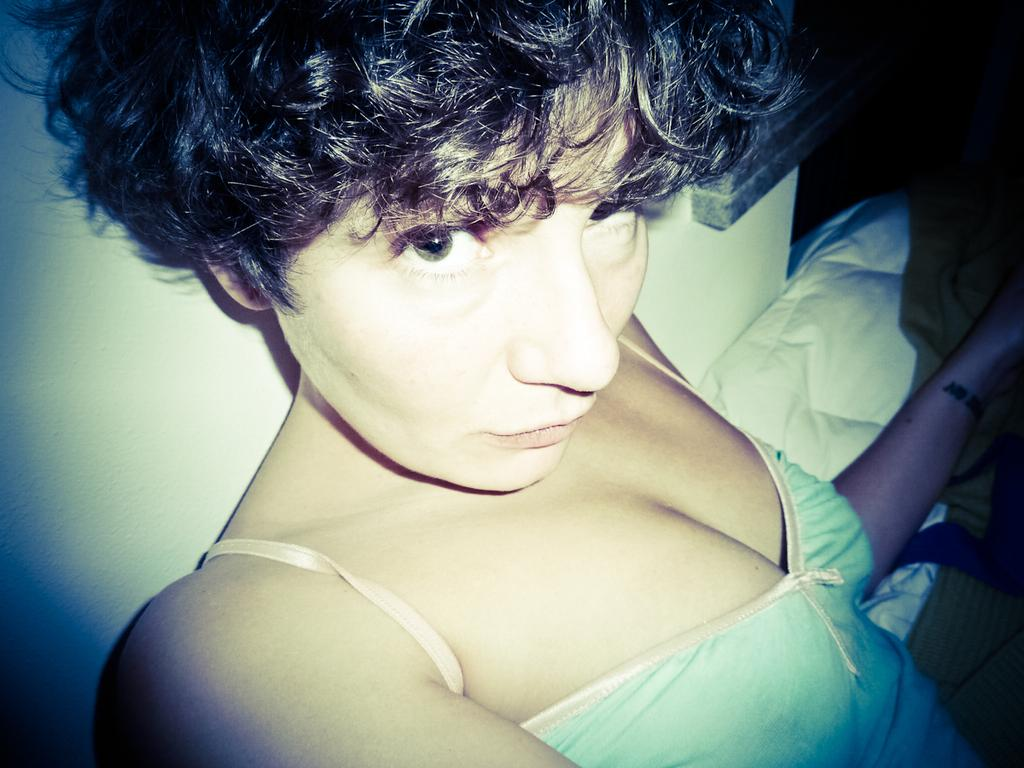What is the woman in the image doing? The woman is sitting in the image. What object is beside the woman? There is a pillow beside the woman. What can be seen in the background of the image? There is a wall in the background of the image. What type of substance is the woman exchanging with the dolls in the image? There is no mention of dolls or any substance exchange in the image. 